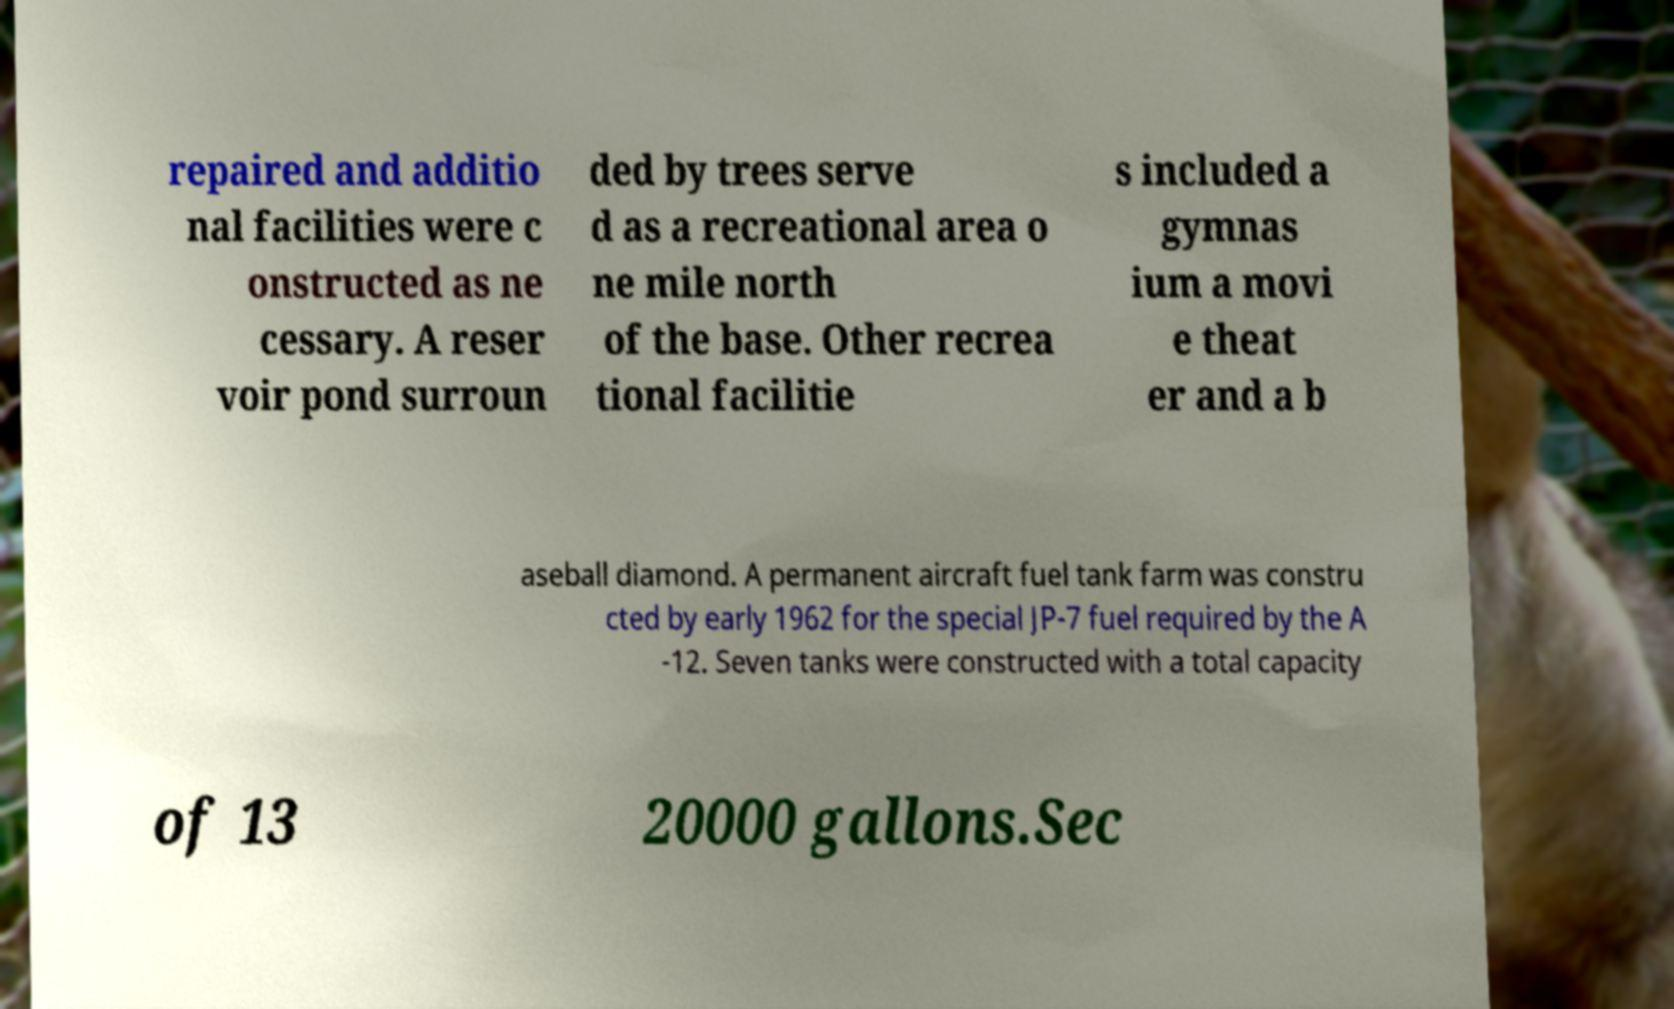For documentation purposes, I need the text within this image transcribed. Could you provide that? repaired and additio nal facilities were c onstructed as ne cessary. A reser voir pond surroun ded by trees serve d as a recreational area o ne mile north of the base. Other recrea tional facilitie s included a gymnas ium a movi e theat er and a b aseball diamond. A permanent aircraft fuel tank farm was constru cted by early 1962 for the special JP-7 fuel required by the A -12. Seven tanks were constructed with a total capacity of 13 20000 gallons.Sec 